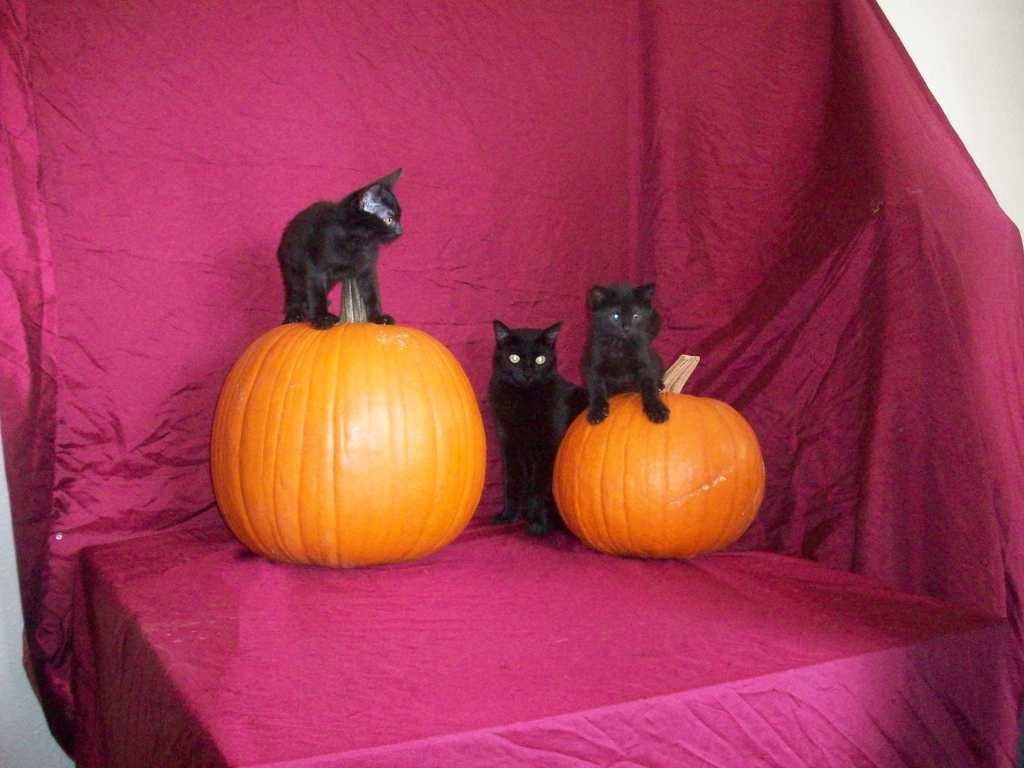What objects are present in the image? There are two pumpkins and three cats in the image. How are the cats positioned in relation to the pumpkins? Two of the cats are on the pumpkins. What color is the cloth in the background of the image? The cloth in the background of the image is pink. What type of lace can be seen on the cats in the image? There is no lace present on the cats in the image. Can you compare the size of the cats to the lamp in the image? There is no lamp present in the image, so it cannot be used for comparison. 